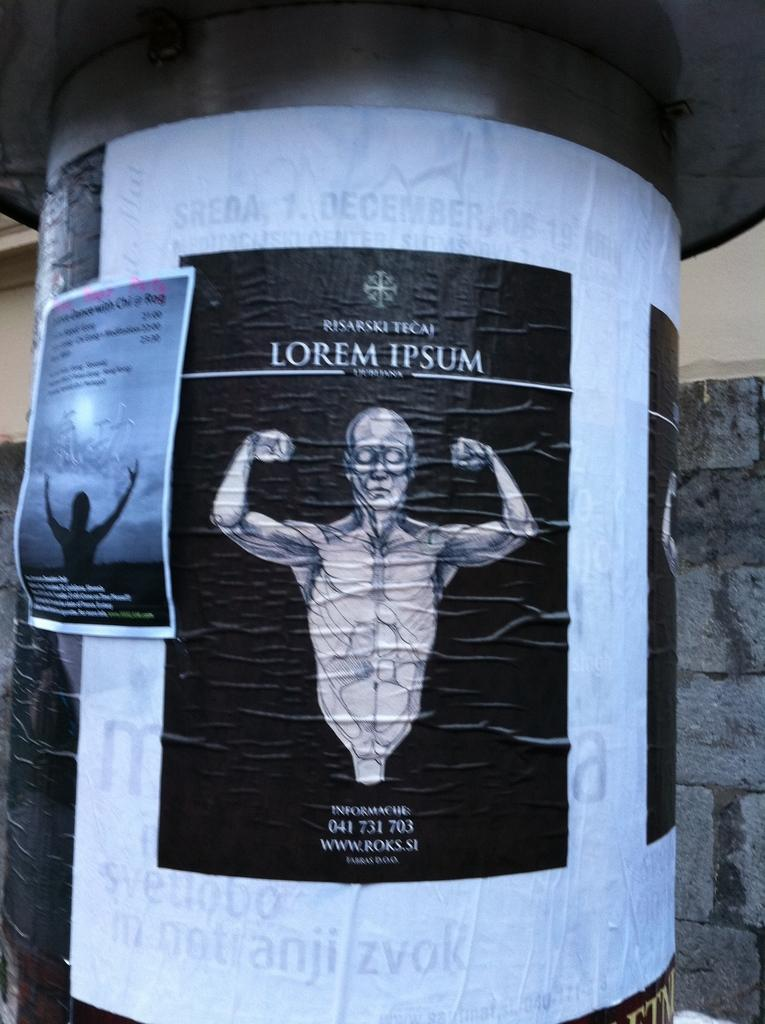What is the main structure in the image? There is a pillar in the image. What is attached to the pillar? There are posters on the pillar. What can be seen in the background of the image? There is a wall visible in the background of the image. What type of skirt is hanging on the wall in the image? There is no skirt present in the image; it features a pillar with posters and a wall in the background. 